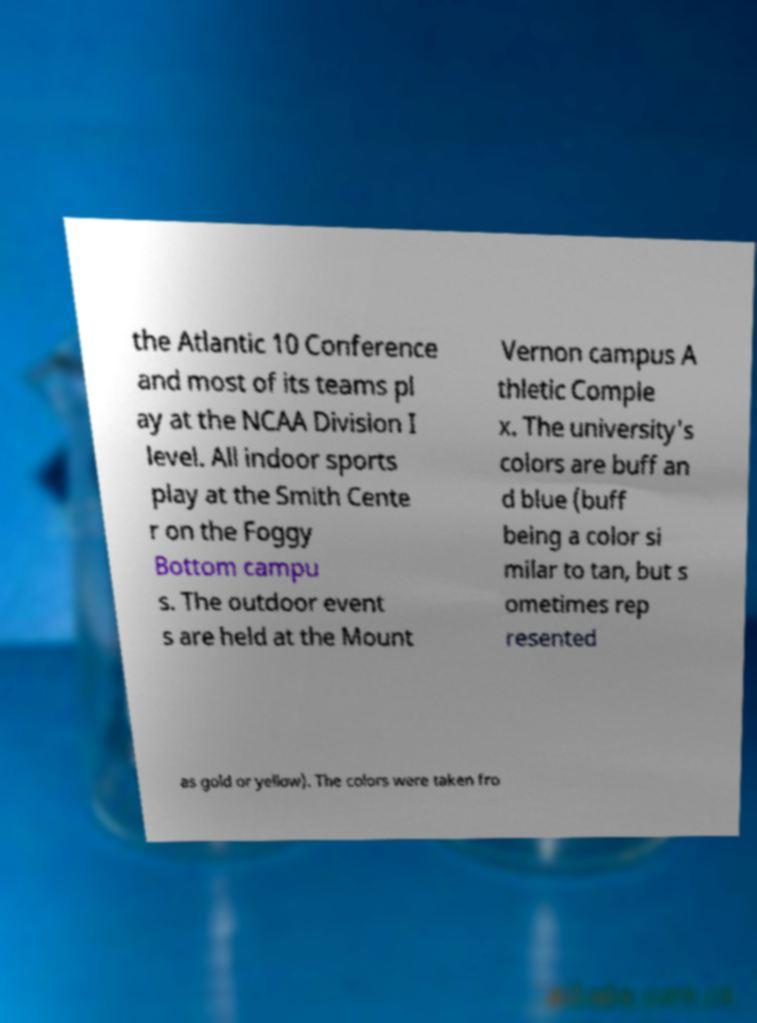Can you accurately transcribe the text from the provided image for me? the Atlantic 10 Conference and most of its teams pl ay at the NCAA Division I level. All indoor sports play at the Smith Cente r on the Foggy Bottom campu s. The outdoor event s are held at the Mount Vernon campus A thletic Comple x. The university's colors are buff an d blue (buff being a color si milar to tan, but s ometimes rep resented as gold or yellow). The colors were taken fro 